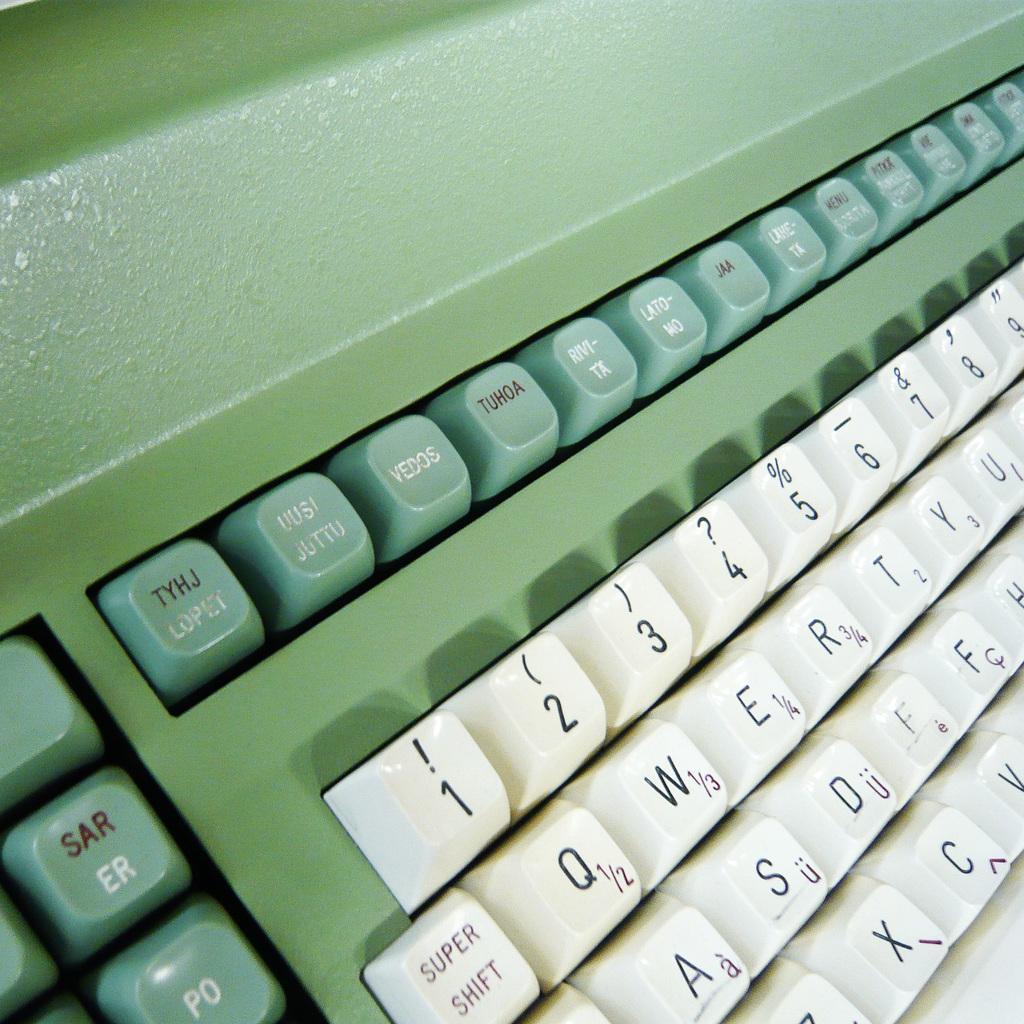<image>
Summarize the visual content of the image. a computer keyboard showing numbers 1 through 9 on the top row 